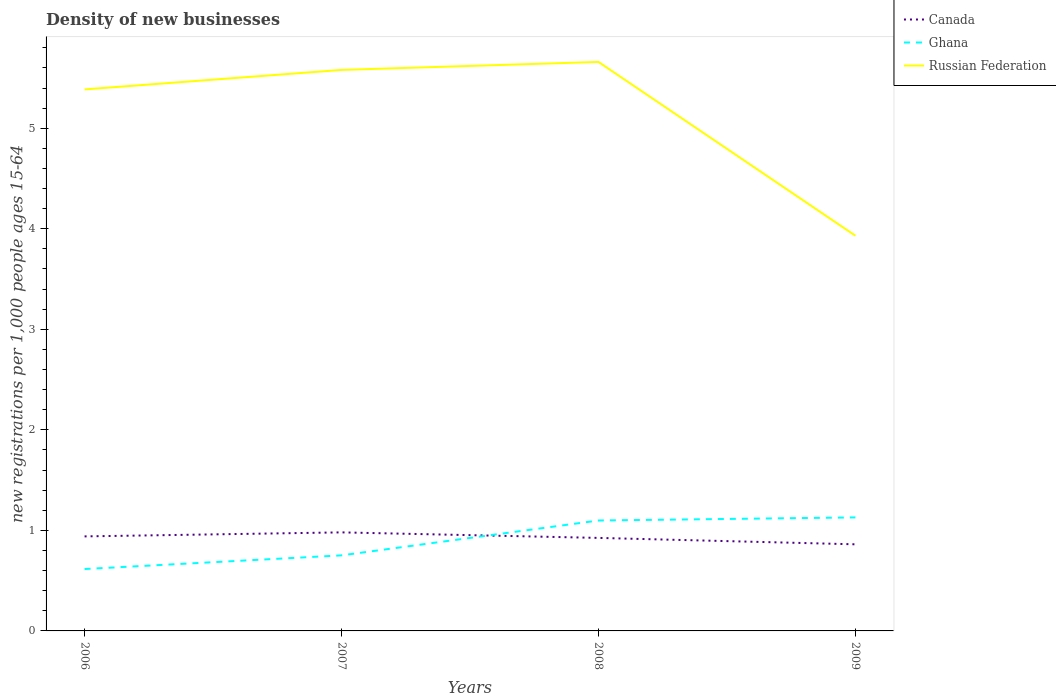How many different coloured lines are there?
Ensure brevity in your answer.  3. Does the line corresponding to Ghana intersect with the line corresponding to Russian Federation?
Give a very brief answer. No. Is the number of lines equal to the number of legend labels?
Offer a terse response. Yes. Across all years, what is the maximum number of new registrations in Ghana?
Your answer should be very brief. 0.62. What is the total number of new registrations in Ghana in the graph?
Keep it short and to the point. -0.14. What is the difference between the highest and the second highest number of new registrations in Canada?
Ensure brevity in your answer.  0.12. Is the number of new registrations in Russian Federation strictly greater than the number of new registrations in Canada over the years?
Your answer should be compact. No. Does the graph contain grids?
Provide a succinct answer. No. How many legend labels are there?
Ensure brevity in your answer.  3. How are the legend labels stacked?
Make the answer very short. Vertical. What is the title of the graph?
Your response must be concise. Density of new businesses. Does "Malta" appear as one of the legend labels in the graph?
Give a very brief answer. No. What is the label or title of the Y-axis?
Your answer should be very brief. New registrations per 1,0 people ages 15-64. What is the new registrations per 1,000 people ages 15-64 in Canada in 2006?
Offer a terse response. 0.94. What is the new registrations per 1,000 people ages 15-64 of Ghana in 2006?
Give a very brief answer. 0.62. What is the new registrations per 1,000 people ages 15-64 in Russian Federation in 2006?
Your answer should be compact. 5.39. What is the new registrations per 1,000 people ages 15-64 of Canada in 2007?
Ensure brevity in your answer.  0.98. What is the new registrations per 1,000 people ages 15-64 in Ghana in 2007?
Provide a short and direct response. 0.75. What is the new registrations per 1,000 people ages 15-64 of Russian Federation in 2007?
Ensure brevity in your answer.  5.58. What is the new registrations per 1,000 people ages 15-64 of Canada in 2008?
Offer a very short reply. 0.93. What is the new registrations per 1,000 people ages 15-64 of Ghana in 2008?
Keep it short and to the point. 1.1. What is the new registrations per 1,000 people ages 15-64 of Russian Federation in 2008?
Offer a terse response. 5.66. What is the new registrations per 1,000 people ages 15-64 of Canada in 2009?
Your answer should be very brief. 0.86. What is the new registrations per 1,000 people ages 15-64 of Ghana in 2009?
Provide a succinct answer. 1.13. What is the new registrations per 1,000 people ages 15-64 in Russian Federation in 2009?
Your answer should be very brief. 3.93. Across all years, what is the maximum new registrations per 1,000 people ages 15-64 of Canada?
Your response must be concise. 0.98. Across all years, what is the maximum new registrations per 1,000 people ages 15-64 of Ghana?
Provide a succinct answer. 1.13. Across all years, what is the maximum new registrations per 1,000 people ages 15-64 of Russian Federation?
Make the answer very short. 5.66. Across all years, what is the minimum new registrations per 1,000 people ages 15-64 of Canada?
Provide a succinct answer. 0.86. Across all years, what is the minimum new registrations per 1,000 people ages 15-64 of Ghana?
Make the answer very short. 0.62. Across all years, what is the minimum new registrations per 1,000 people ages 15-64 of Russian Federation?
Provide a succinct answer. 3.93. What is the total new registrations per 1,000 people ages 15-64 in Canada in the graph?
Your response must be concise. 3.71. What is the total new registrations per 1,000 people ages 15-64 of Ghana in the graph?
Make the answer very short. 3.59. What is the total new registrations per 1,000 people ages 15-64 of Russian Federation in the graph?
Offer a terse response. 20.56. What is the difference between the new registrations per 1,000 people ages 15-64 in Canada in 2006 and that in 2007?
Provide a short and direct response. -0.04. What is the difference between the new registrations per 1,000 people ages 15-64 in Ghana in 2006 and that in 2007?
Your answer should be very brief. -0.14. What is the difference between the new registrations per 1,000 people ages 15-64 of Russian Federation in 2006 and that in 2007?
Ensure brevity in your answer.  -0.19. What is the difference between the new registrations per 1,000 people ages 15-64 in Canada in 2006 and that in 2008?
Give a very brief answer. 0.01. What is the difference between the new registrations per 1,000 people ages 15-64 of Ghana in 2006 and that in 2008?
Offer a terse response. -0.48. What is the difference between the new registrations per 1,000 people ages 15-64 of Russian Federation in 2006 and that in 2008?
Offer a very short reply. -0.27. What is the difference between the new registrations per 1,000 people ages 15-64 in Canada in 2006 and that in 2009?
Offer a terse response. 0.08. What is the difference between the new registrations per 1,000 people ages 15-64 of Ghana in 2006 and that in 2009?
Provide a succinct answer. -0.51. What is the difference between the new registrations per 1,000 people ages 15-64 of Russian Federation in 2006 and that in 2009?
Offer a terse response. 1.46. What is the difference between the new registrations per 1,000 people ages 15-64 of Canada in 2007 and that in 2008?
Provide a succinct answer. 0.06. What is the difference between the new registrations per 1,000 people ages 15-64 of Ghana in 2007 and that in 2008?
Provide a succinct answer. -0.35. What is the difference between the new registrations per 1,000 people ages 15-64 of Russian Federation in 2007 and that in 2008?
Offer a very short reply. -0.08. What is the difference between the new registrations per 1,000 people ages 15-64 in Canada in 2007 and that in 2009?
Keep it short and to the point. 0.12. What is the difference between the new registrations per 1,000 people ages 15-64 in Ghana in 2007 and that in 2009?
Provide a short and direct response. -0.38. What is the difference between the new registrations per 1,000 people ages 15-64 in Russian Federation in 2007 and that in 2009?
Give a very brief answer. 1.65. What is the difference between the new registrations per 1,000 people ages 15-64 in Canada in 2008 and that in 2009?
Offer a very short reply. 0.06. What is the difference between the new registrations per 1,000 people ages 15-64 in Ghana in 2008 and that in 2009?
Make the answer very short. -0.03. What is the difference between the new registrations per 1,000 people ages 15-64 in Russian Federation in 2008 and that in 2009?
Provide a succinct answer. 1.73. What is the difference between the new registrations per 1,000 people ages 15-64 in Canada in 2006 and the new registrations per 1,000 people ages 15-64 in Ghana in 2007?
Offer a terse response. 0.19. What is the difference between the new registrations per 1,000 people ages 15-64 of Canada in 2006 and the new registrations per 1,000 people ages 15-64 of Russian Federation in 2007?
Ensure brevity in your answer.  -4.64. What is the difference between the new registrations per 1,000 people ages 15-64 in Ghana in 2006 and the new registrations per 1,000 people ages 15-64 in Russian Federation in 2007?
Your answer should be compact. -4.96. What is the difference between the new registrations per 1,000 people ages 15-64 in Canada in 2006 and the new registrations per 1,000 people ages 15-64 in Ghana in 2008?
Give a very brief answer. -0.16. What is the difference between the new registrations per 1,000 people ages 15-64 of Canada in 2006 and the new registrations per 1,000 people ages 15-64 of Russian Federation in 2008?
Offer a very short reply. -4.72. What is the difference between the new registrations per 1,000 people ages 15-64 of Ghana in 2006 and the new registrations per 1,000 people ages 15-64 of Russian Federation in 2008?
Your response must be concise. -5.04. What is the difference between the new registrations per 1,000 people ages 15-64 of Canada in 2006 and the new registrations per 1,000 people ages 15-64 of Ghana in 2009?
Your answer should be very brief. -0.19. What is the difference between the new registrations per 1,000 people ages 15-64 in Canada in 2006 and the new registrations per 1,000 people ages 15-64 in Russian Federation in 2009?
Your response must be concise. -2.99. What is the difference between the new registrations per 1,000 people ages 15-64 in Ghana in 2006 and the new registrations per 1,000 people ages 15-64 in Russian Federation in 2009?
Give a very brief answer. -3.32. What is the difference between the new registrations per 1,000 people ages 15-64 in Canada in 2007 and the new registrations per 1,000 people ages 15-64 in Ghana in 2008?
Your answer should be very brief. -0.12. What is the difference between the new registrations per 1,000 people ages 15-64 in Canada in 2007 and the new registrations per 1,000 people ages 15-64 in Russian Federation in 2008?
Your answer should be compact. -4.68. What is the difference between the new registrations per 1,000 people ages 15-64 in Ghana in 2007 and the new registrations per 1,000 people ages 15-64 in Russian Federation in 2008?
Give a very brief answer. -4.91. What is the difference between the new registrations per 1,000 people ages 15-64 in Canada in 2007 and the new registrations per 1,000 people ages 15-64 in Ghana in 2009?
Your response must be concise. -0.15. What is the difference between the new registrations per 1,000 people ages 15-64 in Canada in 2007 and the new registrations per 1,000 people ages 15-64 in Russian Federation in 2009?
Provide a succinct answer. -2.95. What is the difference between the new registrations per 1,000 people ages 15-64 in Ghana in 2007 and the new registrations per 1,000 people ages 15-64 in Russian Federation in 2009?
Offer a very short reply. -3.18. What is the difference between the new registrations per 1,000 people ages 15-64 in Canada in 2008 and the new registrations per 1,000 people ages 15-64 in Ghana in 2009?
Provide a succinct answer. -0.2. What is the difference between the new registrations per 1,000 people ages 15-64 of Canada in 2008 and the new registrations per 1,000 people ages 15-64 of Russian Federation in 2009?
Keep it short and to the point. -3.01. What is the difference between the new registrations per 1,000 people ages 15-64 of Ghana in 2008 and the new registrations per 1,000 people ages 15-64 of Russian Federation in 2009?
Your answer should be compact. -2.83. What is the average new registrations per 1,000 people ages 15-64 in Canada per year?
Your response must be concise. 0.93. What is the average new registrations per 1,000 people ages 15-64 in Ghana per year?
Offer a terse response. 0.9. What is the average new registrations per 1,000 people ages 15-64 of Russian Federation per year?
Make the answer very short. 5.14. In the year 2006, what is the difference between the new registrations per 1,000 people ages 15-64 in Canada and new registrations per 1,000 people ages 15-64 in Ghana?
Make the answer very short. 0.32. In the year 2006, what is the difference between the new registrations per 1,000 people ages 15-64 in Canada and new registrations per 1,000 people ages 15-64 in Russian Federation?
Provide a succinct answer. -4.45. In the year 2006, what is the difference between the new registrations per 1,000 people ages 15-64 of Ghana and new registrations per 1,000 people ages 15-64 of Russian Federation?
Ensure brevity in your answer.  -4.77. In the year 2007, what is the difference between the new registrations per 1,000 people ages 15-64 of Canada and new registrations per 1,000 people ages 15-64 of Ghana?
Your answer should be very brief. 0.23. In the year 2007, what is the difference between the new registrations per 1,000 people ages 15-64 of Canada and new registrations per 1,000 people ages 15-64 of Russian Federation?
Make the answer very short. -4.6. In the year 2007, what is the difference between the new registrations per 1,000 people ages 15-64 in Ghana and new registrations per 1,000 people ages 15-64 in Russian Federation?
Give a very brief answer. -4.83. In the year 2008, what is the difference between the new registrations per 1,000 people ages 15-64 of Canada and new registrations per 1,000 people ages 15-64 of Ghana?
Give a very brief answer. -0.17. In the year 2008, what is the difference between the new registrations per 1,000 people ages 15-64 of Canada and new registrations per 1,000 people ages 15-64 of Russian Federation?
Give a very brief answer. -4.73. In the year 2008, what is the difference between the new registrations per 1,000 people ages 15-64 in Ghana and new registrations per 1,000 people ages 15-64 in Russian Federation?
Make the answer very short. -4.56. In the year 2009, what is the difference between the new registrations per 1,000 people ages 15-64 in Canada and new registrations per 1,000 people ages 15-64 in Ghana?
Keep it short and to the point. -0.27. In the year 2009, what is the difference between the new registrations per 1,000 people ages 15-64 in Canada and new registrations per 1,000 people ages 15-64 in Russian Federation?
Give a very brief answer. -3.07. In the year 2009, what is the difference between the new registrations per 1,000 people ages 15-64 in Ghana and new registrations per 1,000 people ages 15-64 in Russian Federation?
Your answer should be very brief. -2.8. What is the ratio of the new registrations per 1,000 people ages 15-64 of Canada in 2006 to that in 2007?
Your answer should be very brief. 0.96. What is the ratio of the new registrations per 1,000 people ages 15-64 in Ghana in 2006 to that in 2007?
Your answer should be very brief. 0.82. What is the ratio of the new registrations per 1,000 people ages 15-64 of Russian Federation in 2006 to that in 2007?
Your answer should be compact. 0.97. What is the ratio of the new registrations per 1,000 people ages 15-64 in Canada in 2006 to that in 2008?
Provide a succinct answer. 1.02. What is the ratio of the new registrations per 1,000 people ages 15-64 in Ghana in 2006 to that in 2008?
Make the answer very short. 0.56. What is the ratio of the new registrations per 1,000 people ages 15-64 in Russian Federation in 2006 to that in 2008?
Provide a succinct answer. 0.95. What is the ratio of the new registrations per 1,000 people ages 15-64 of Canada in 2006 to that in 2009?
Provide a short and direct response. 1.09. What is the ratio of the new registrations per 1,000 people ages 15-64 in Ghana in 2006 to that in 2009?
Provide a succinct answer. 0.55. What is the ratio of the new registrations per 1,000 people ages 15-64 of Russian Federation in 2006 to that in 2009?
Offer a very short reply. 1.37. What is the ratio of the new registrations per 1,000 people ages 15-64 in Canada in 2007 to that in 2008?
Provide a succinct answer. 1.06. What is the ratio of the new registrations per 1,000 people ages 15-64 of Ghana in 2007 to that in 2008?
Your answer should be compact. 0.68. What is the ratio of the new registrations per 1,000 people ages 15-64 in Canada in 2007 to that in 2009?
Your response must be concise. 1.14. What is the ratio of the new registrations per 1,000 people ages 15-64 in Ghana in 2007 to that in 2009?
Make the answer very short. 0.67. What is the ratio of the new registrations per 1,000 people ages 15-64 of Russian Federation in 2007 to that in 2009?
Provide a succinct answer. 1.42. What is the ratio of the new registrations per 1,000 people ages 15-64 of Canada in 2008 to that in 2009?
Ensure brevity in your answer.  1.07. What is the ratio of the new registrations per 1,000 people ages 15-64 in Ghana in 2008 to that in 2009?
Keep it short and to the point. 0.97. What is the ratio of the new registrations per 1,000 people ages 15-64 of Russian Federation in 2008 to that in 2009?
Ensure brevity in your answer.  1.44. What is the difference between the highest and the second highest new registrations per 1,000 people ages 15-64 in Canada?
Give a very brief answer. 0.04. What is the difference between the highest and the second highest new registrations per 1,000 people ages 15-64 of Ghana?
Ensure brevity in your answer.  0.03. What is the difference between the highest and the second highest new registrations per 1,000 people ages 15-64 in Russian Federation?
Your answer should be very brief. 0.08. What is the difference between the highest and the lowest new registrations per 1,000 people ages 15-64 of Canada?
Your answer should be very brief. 0.12. What is the difference between the highest and the lowest new registrations per 1,000 people ages 15-64 in Ghana?
Offer a terse response. 0.51. What is the difference between the highest and the lowest new registrations per 1,000 people ages 15-64 of Russian Federation?
Provide a short and direct response. 1.73. 